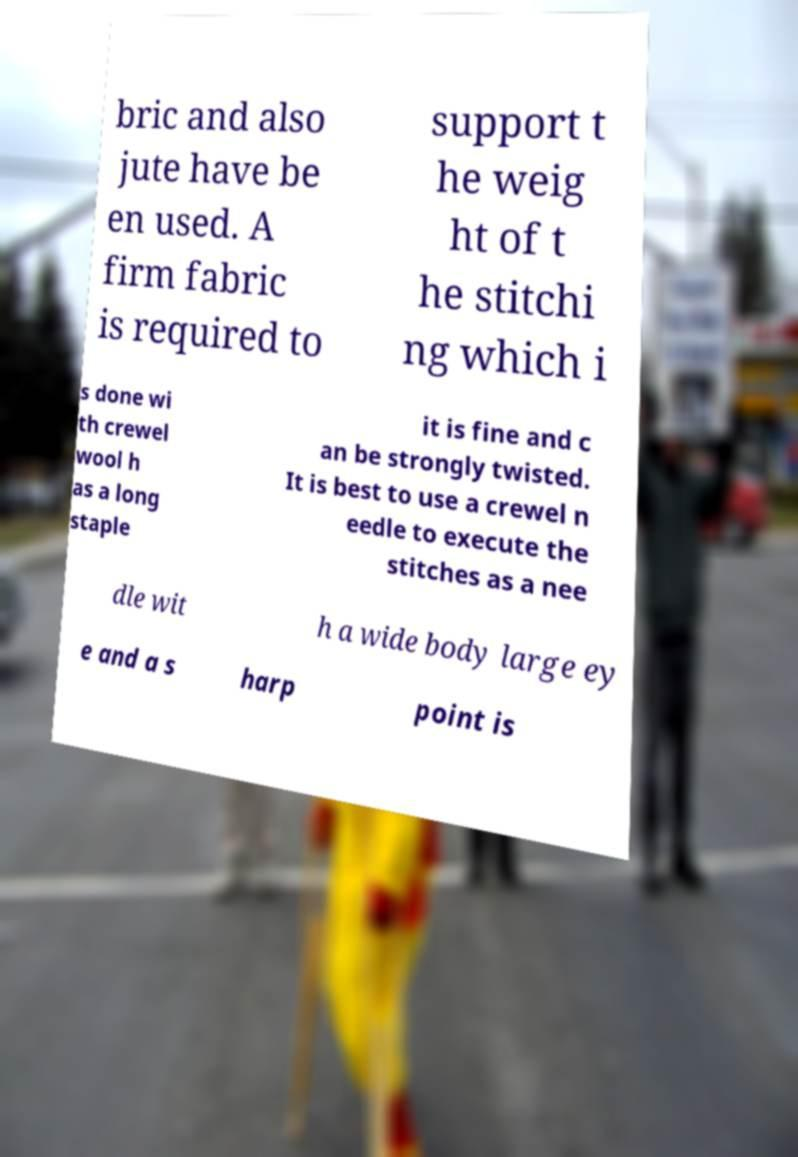Can you accurately transcribe the text from the provided image for me? bric and also jute have be en used. A firm fabric is required to support t he weig ht of t he stitchi ng which i s done wi th crewel wool h as a long staple it is fine and c an be strongly twisted. It is best to use a crewel n eedle to execute the stitches as a nee dle wit h a wide body large ey e and a s harp point is 